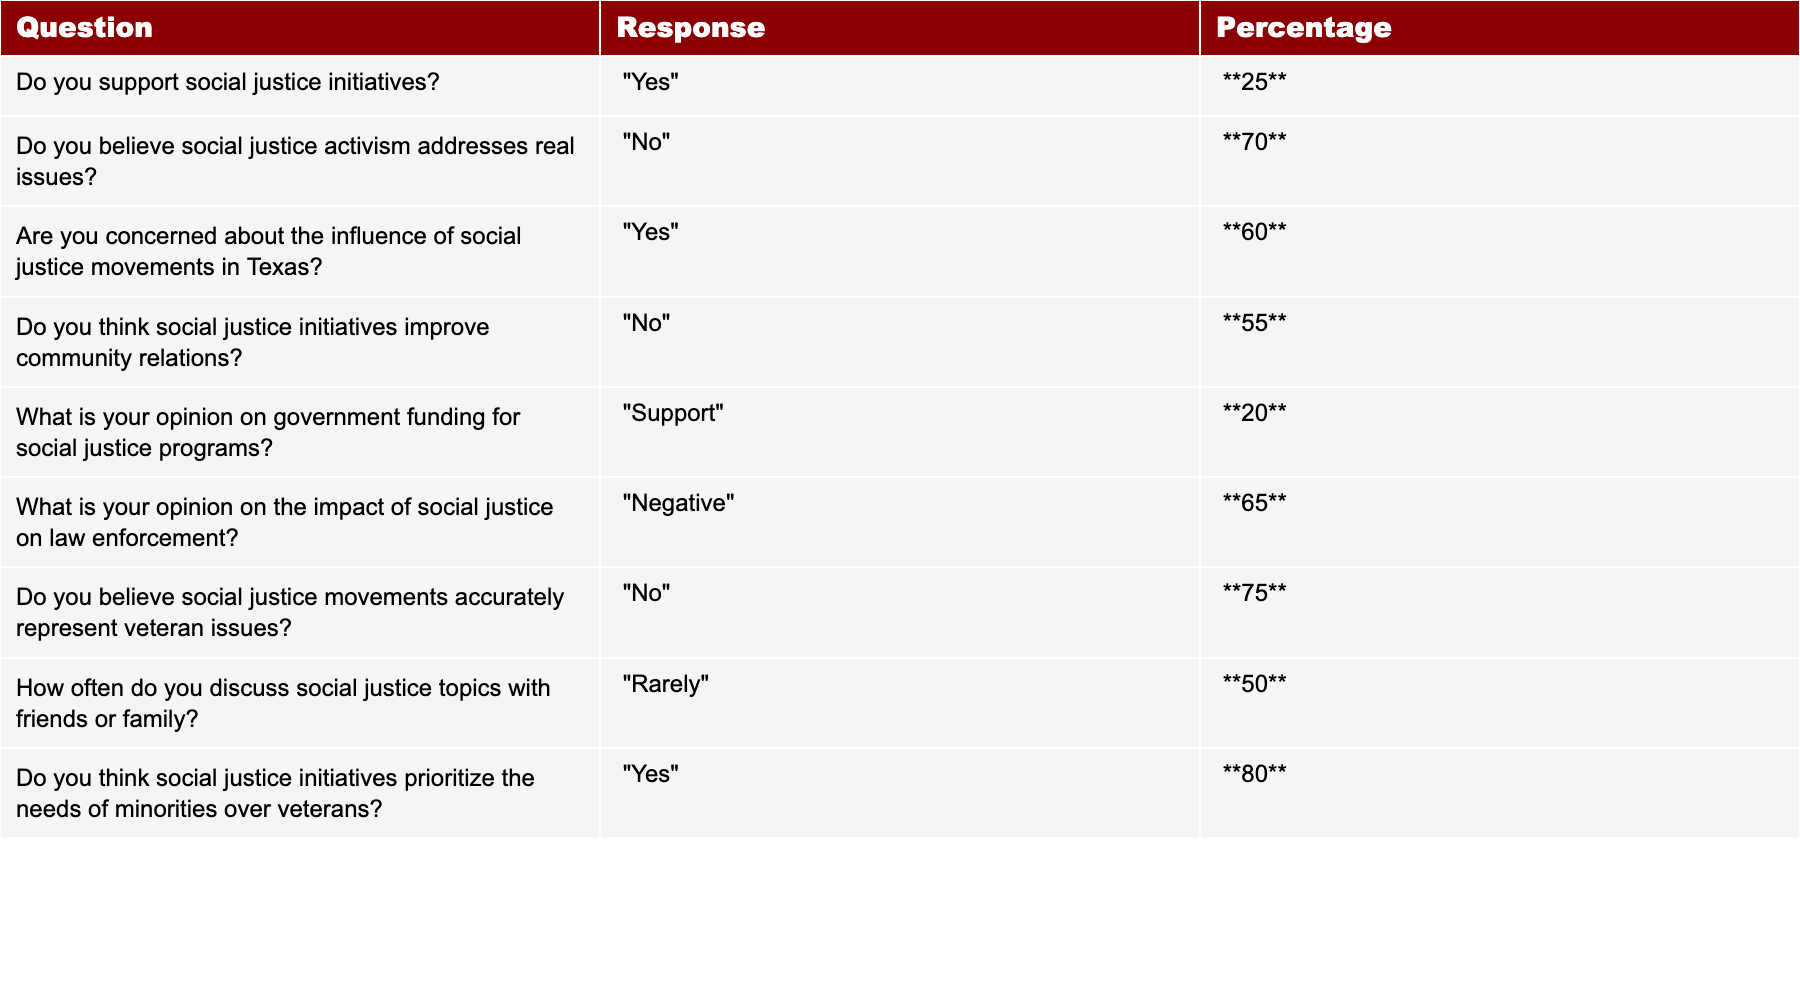What percentage of respondents support social justice initiatives? The table indicates a response of "Yes" to the question about supporting social justice initiatives with a percentage of **25**.
Answer: 25 What is the majority opinion on whether social justice activism addresses real issues? The majority response to this question is "No," with **70**% of respondents indicating they believe social justice activism does not address real issues.
Answer: 70 How many respondents are concerned about the influence of social justice movements in Texas? According to the table, **60**% of respondents answered "Yes" to being concerned about the influence of social justice movements, representing a majority.
Answer: 60 What is the percentage of people who believe social justice initiatives improve community relations? The table shows that the response of "No" is recorded at **55**%, indicating that the majority do not believe initiatives improve community relations.
Answer: 55 What is the overall support for government funding of social justice programs? The table reflects a low support percentage of **20**% among respondents, indicating that the majority do not support government funding for these programs.
Answer: 20 What is the perceived impact of social justice on law enforcement according to respondents? The table presents **65**% of respondents with a "Negative" view regarding the impact of social justice on law enforcement, indicating a significant concern.
Answer: 65 Do most respondents believe social justice movements accurately represent veteran issues? The majority, at **75**%, believe that social justice movements do not accurately represent veteran issues, suggesting a disconnect.
Answer: 75 How often do respondents discuss social justice topics with family or friends? The table indicates that **50**% of respondents "Rarely" discuss social justice topics, suggesting limited engagement in conversations about these issues.
Answer: 50 What is the percentage of respondents who think social justice initiatives prioritize minorities over veterans? The table shows **80**% of respondents believe that social justice initiatives prioritize the needs of minorities over those of veterans, indicating a strong sentiment about this issue.
Answer: 80 What is the difference in percentage between those who support social justice initiatives and those who believe it prioritizes minorities over veterans? Support for social justice initiatives is **25%**, and those who believe it prioritizes minorities is **80%**. The difference is 80 - 25 = 55.
Answer: 55 